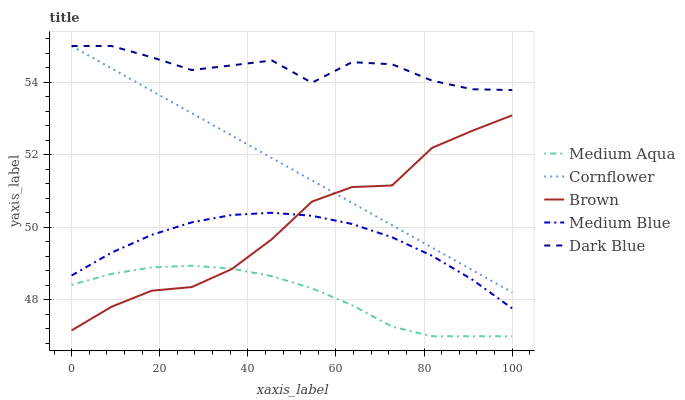Does Medium Aqua have the minimum area under the curve?
Answer yes or no. Yes. Does Dark Blue have the maximum area under the curve?
Answer yes or no. Yes. Does Dark Blue have the minimum area under the curve?
Answer yes or no. No. Does Medium Aqua have the maximum area under the curve?
Answer yes or no. No. Is Cornflower the smoothest?
Answer yes or no. Yes. Is Dark Blue the roughest?
Answer yes or no. Yes. Is Medium Aqua the smoothest?
Answer yes or no. No. Is Medium Aqua the roughest?
Answer yes or no. No. Does Medium Aqua have the lowest value?
Answer yes or no. Yes. Does Dark Blue have the lowest value?
Answer yes or no. No. Does Dark Blue have the highest value?
Answer yes or no. Yes. Does Medium Aqua have the highest value?
Answer yes or no. No. Is Medium Blue less than Cornflower?
Answer yes or no. Yes. Is Dark Blue greater than Medium Aqua?
Answer yes or no. Yes. Does Cornflower intersect Brown?
Answer yes or no. Yes. Is Cornflower less than Brown?
Answer yes or no. No. Is Cornflower greater than Brown?
Answer yes or no. No. Does Medium Blue intersect Cornflower?
Answer yes or no. No. 